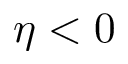<formula> <loc_0><loc_0><loc_500><loc_500>\eta < 0</formula> 